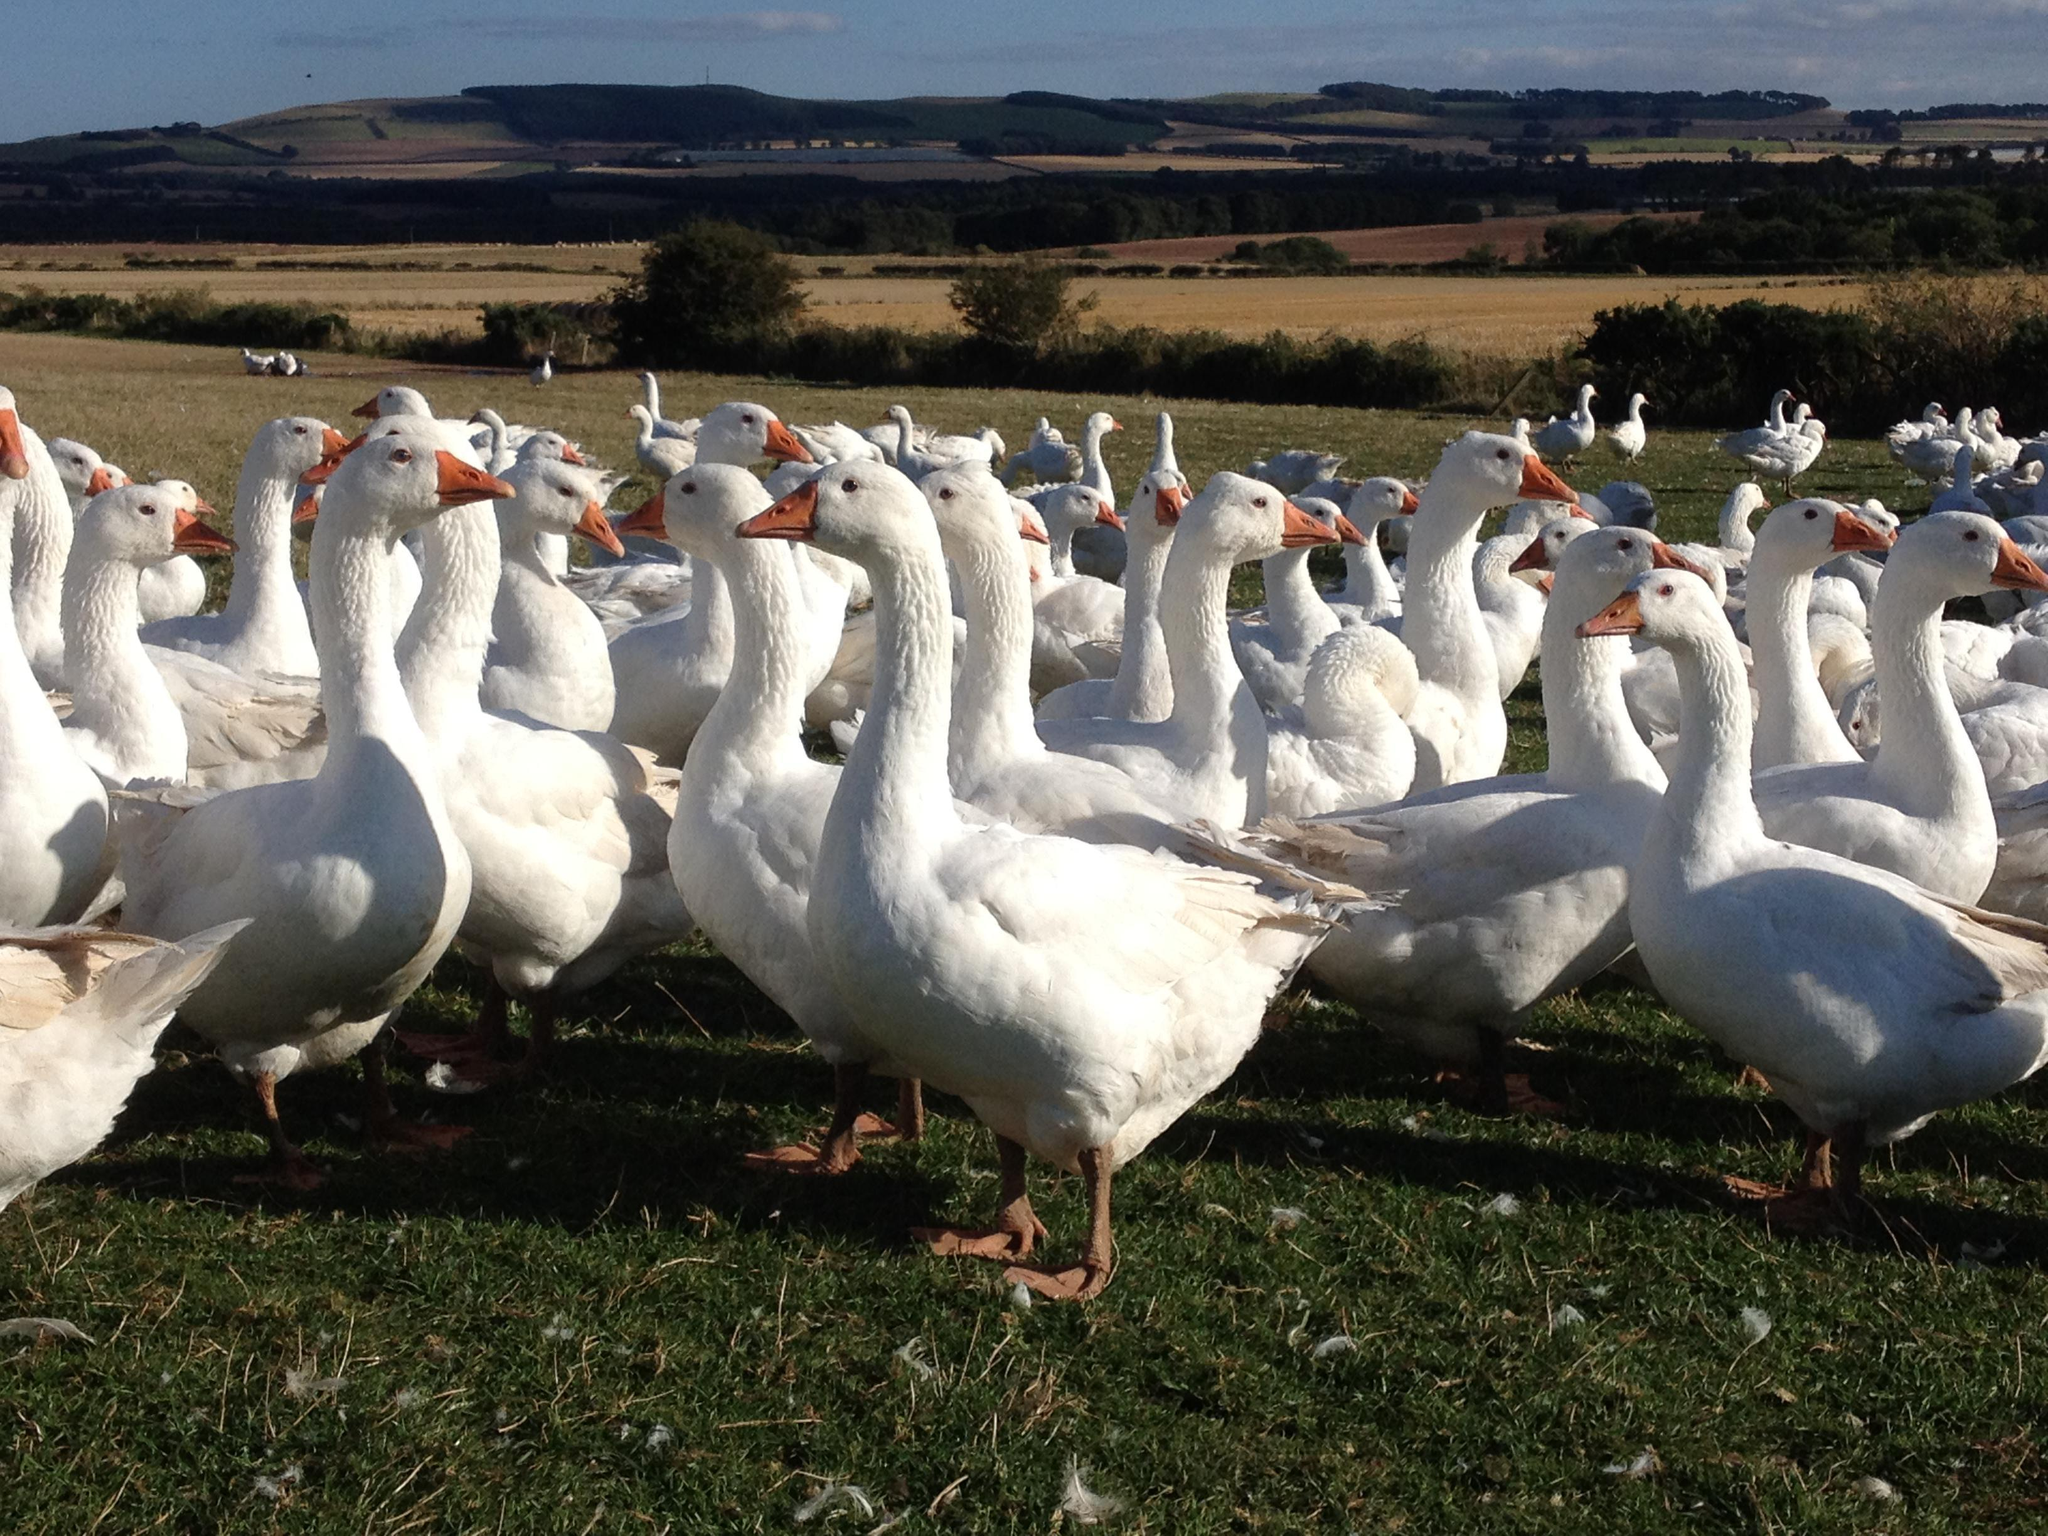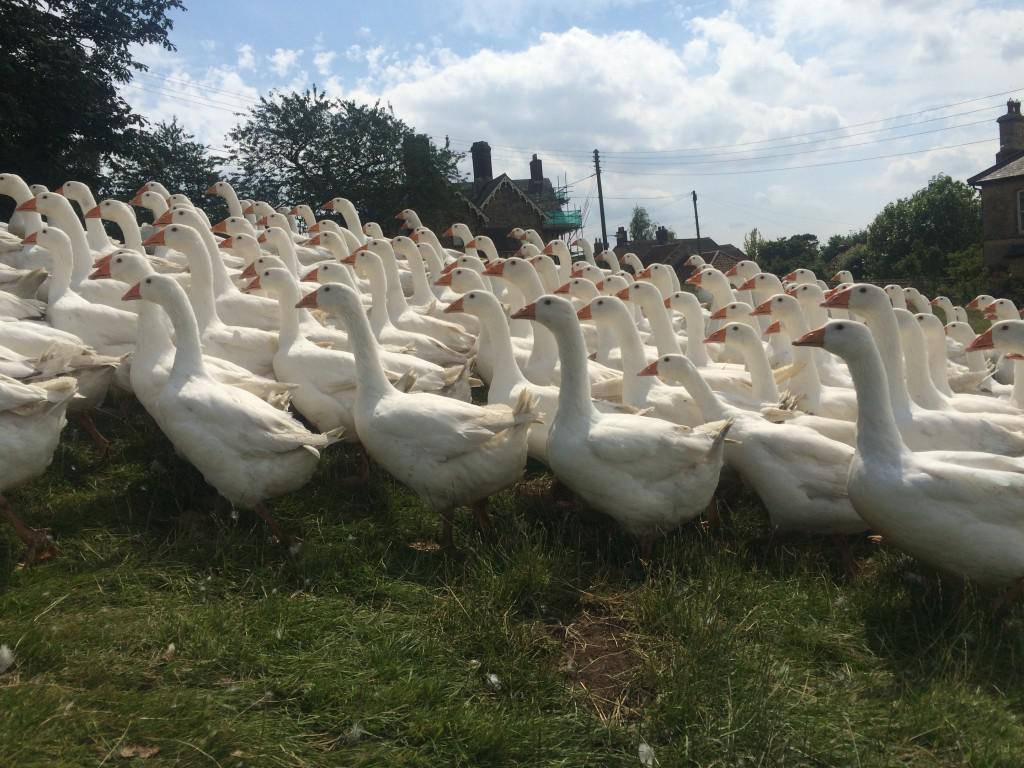The first image is the image on the left, the second image is the image on the right. Examine the images to the left and right. Is the description "In at least one image there is at least one black and grey duck facing right in the water." accurate? Answer yes or no. No. The first image is the image on the left, the second image is the image on the right. Given the left and right images, does the statement "The canada geese are in the water." hold true? Answer yes or no. No. 